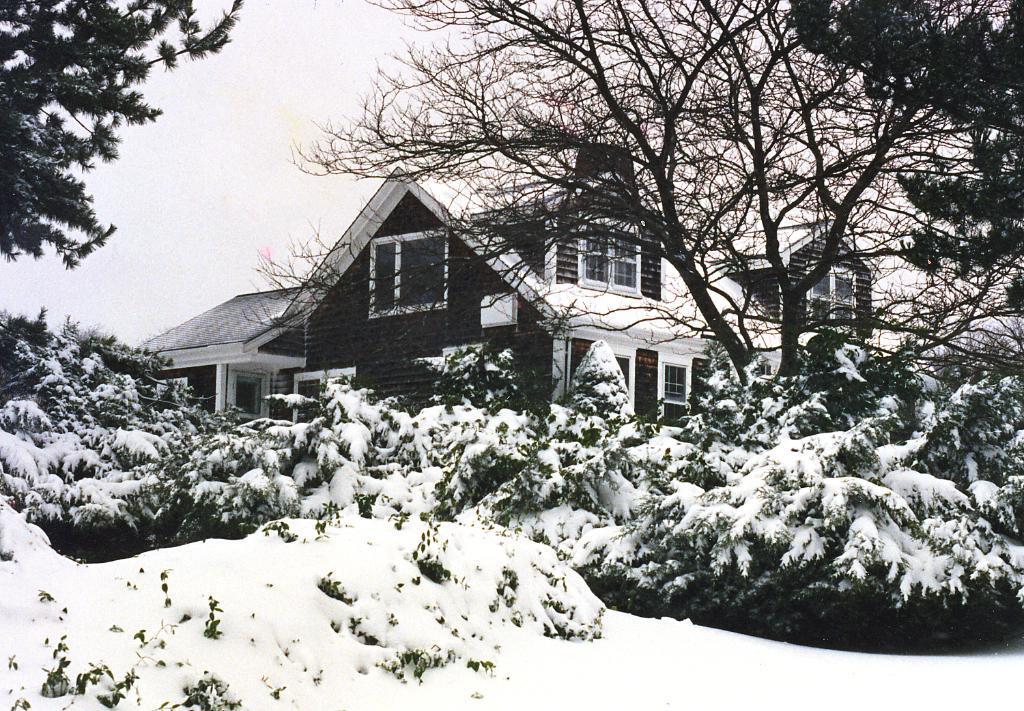Can you describe this image briefly? This image is taken outdoors. At the bottom of the image there is a ground covered with snow. At the top of the image there is a sky. In the background there is a house with a few walls, windows, a door and a roof. In the middle of the image there are many plants and trees. 